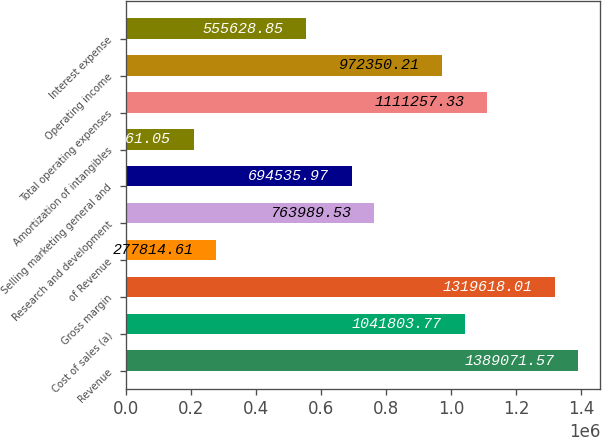Convert chart. <chart><loc_0><loc_0><loc_500><loc_500><bar_chart><fcel>Revenue<fcel>Cost of sales (a)<fcel>Gross margin<fcel>of Revenue<fcel>Research and development<fcel>Selling marketing general and<fcel>Amortization of intangibles<fcel>Total operating expenses<fcel>Operating income<fcel>Interest expense<nl><fcel>1.38907e+06<fcel>1.0418e+06<fcel>1.31962e+06<fcel>277815<fcel>763990<fcel>694536<fcel>208361<fcel>1.11126e+06<fcel>972350<fcel>555629<nl></chart> 